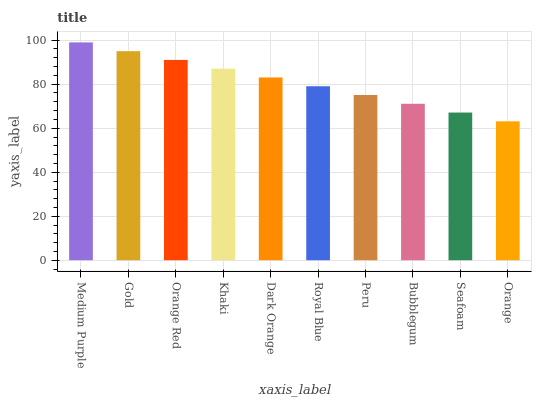Is Orange the minimum?
Answer yes or no. Yes. Is Medium Purple the maximum?
Answer yes or no. Yes. Is Gold the minimum?
Answer yes or no. No. Is Gold the maximum?
Answer yes or no. No. Is Medium Purple greater than Gold?
Answer yes or no. Yes. Is Gold less than Medium Purple?
Answer yes or no. Yes. Is Gold greater than Medium Purple?
Answer yes or no. No. Is Medium Purple less than Gold?
Answer yes or no. No. Is Dark Orange the high median?
Answer yes or no. Yes. Is Royal Blue the low median?
Answer yes or no. Yes. Is Seafoam the high median?
Answer yes or no. No. Is Bubblegum the low median?
Answer yes or no. No. 